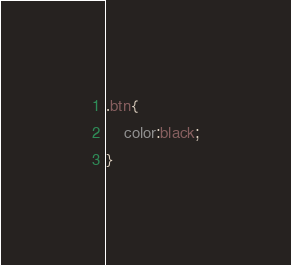<code> <loc_0><loc_0><loc_500><loc_500><_CSS_>.btn{
    color:black;
}
</code> 